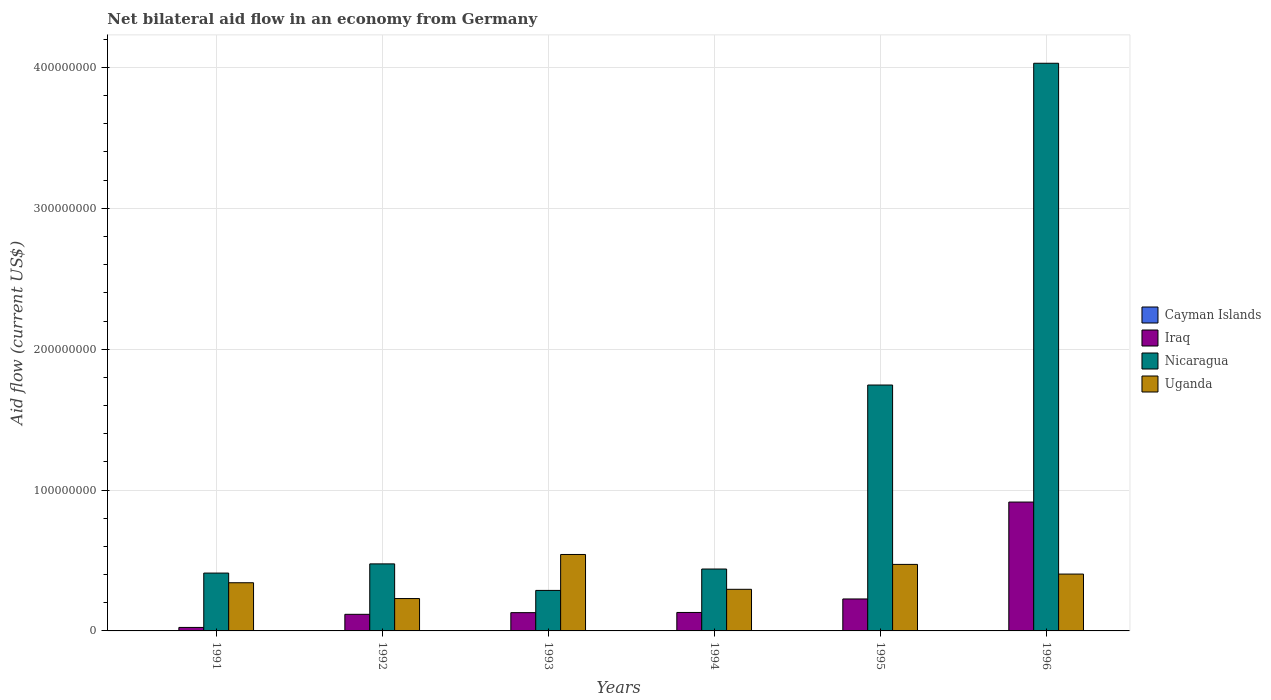Are the number of bars per tick equal to the number of legend labels?
Offer a very short reply. No. Are the number of bars on each tick of the X-axis equal?
Offer a very short reply. Yes. How many bars are there on the 1st tick from the right?
Your answer should be very brief. 3. What is the label of the 1st group of bars from the left?
Your answer should be compact. 1991. In how many cases, is the number of bars for a given year not equal to the number of legend labels?
Keep it short and to the point. 6. What is the net bilateral aid flow in Iraq in 1993?
Keep it short and to the point. 1.30e+07. Across all years, what is the maximum net bilateral aid flow in Uganda?
Your answer should be compact. 5.43e+07. Across all years, what is the minimum net bilateral aid flow in Nicaragua?
Your answer should be very brief. 2.88e+07. What is the total net bilateral aid flow in Iraq in the graph?
Keep it short and to the point. 1.55e+08. What is the difference between the net bilateral aid flow in Nicaragua in 1991 and that in 1995?
Ensure brevity in your answer.  -1.33e+08. What is the difference between the net bilateral aid flow in Iraq in 1993 and the net bilateral aid flow in Nicaragua in 1994?
Provide a succinct answer. -3.10e+07. What is the average net bilateral aid flow in Uganda per year?
Provide a short and direct response. 3.81e+07. In the year 1995, what is the difference between the net bilateral aid flow in Nicaragua and net bilateral aid flow in Uganda?
Keep it short and to the point. 1.27e+08. What is the ratio of the net bilateral aid flow in Uganda in 1994 to that in 1996?
Your response must be concise. 0.73. What is the difference between the highest and the second highest net bilateral aid flow in Uganda?
Ensure brevity in your answer.  7.05e+06. What is the difference between the highest and the lowest net bilateral aid flow in Iraq?
Make the answer very short. 8.90e+07. Is the sum of the net bilateral aid flow in Uganda in 1994 and 1996 greater than the maximum net bilateral aid flow in Nicaragua across all years?
Offer a very short reply. No. Is it the case that in every year, the sum of the net bilateral aid flow in Nicaragua and net bilateral aid flow in Uganda is greater than the net bilateral aid flow in Iraq?
Offer a terse response. Yes. How many bars are there?
Offer a very short reply. 18. How many years are there in the graph?
Your answer should be very brief. 6. Does the graph contain grids?
Give a very brief answer. Yes. What is the title of the graph?
Offer a very short reply. Net bilateral aid flow in an economy from Germany. What is the label or title of the X-axis?
Offer a terse response. Years. What is the label or title of the Y-axis?
Provide a short and direct response. Aid flow (current US$). What is the Aid flow (current US$) of Cayman Islands in 1991?
Ensure brevity in your answer.  0. What is the Aid flow (current US$) of Iraq in 1991?
Offer a terse response. 2.48e+06. What is the Aid flow (current US$) of Nicaragua in 1991?
Your answer should be very brief. 4.11e+07. What is the Aid flow (current US$) of Uganda in 1991?
Your answer should be very brief. 3.42e+07. What is the Aid flow (current US$) of Iraq in 1992?
Your response must be concise. 1.18e+07. What is the Aid flow (current US$) in Nicaragua in 1992?
Ensure brevity in your answer.  4.76e+07. What is the Aid flow (current US$) of Uganda in 1992?
Make the answer very short. 2.30e+07. What is the Aid flow (current US$) in Cayman Islands in 1993?
Make the answer very short. 0. What is the Aid flow (current US$) in Iraq in 1993?
Offer a terse response. 1.30e+07. What is the Aid flow (current US$) of Nicaragua in 1993?
Keep it short and to the point. 2.88e+07. What is the Aid flow (current US$) in Uganda in 1993?
Offer a terse response. 5.43e+07. What is the Aid flow (current US$) of Cayman Islands in 1994?
Keep it short and to the point. 0. What is the Aid flow (current US$) in Iraq in 1994?
Provide a succinct answer. 1.31e+07. What is the Aid flow (current US$) of Nicaragua in 1994?
Give a very brief answer. 4.39e+07. What is the Aid flow (current US$) in Uganda in 1994?
Provide a succinct answer. 2.95e+07. What is the Aid flow (current US$) in Iraq in 1995?
Provide a short and direct response. 2.27e+07. What is the Aid flow (current US$) in Nicaragua in 1995?
Keep it short and to the point. 1.75e+08. What is the Aid flow (current US$) in Uganda in 1995?
Your answer should be compact. 4.72e+07. What is the Aid flow (current US$) in Iraq in 1996?
Provide a short and direct response. 9.15e+07. What is the Aid flow (current US$) of Nicaragua in 1996?
Your answer should be compact. 4.03e+08. What is the Aid flow (current US$) in Uganda in 1996?
Keep it short and to the point. 4.04e+07. Across all years, what is the maximum Aid flow (current US$) in Iraq?
Ensure brevity in your answer.  9.15e+07. Across all years, what is the maximum Aid flow (current US$) in Nicaragua?
Provide a short and direct response. 4.03e+08. Across all years, what is the maximum Aid flow (current US$) of Uganda?
Your answer should be compact. 5.43e+07. Across all years, what is the minimum Aid flow (current US$) of Iraq?
Give a very brief answer. 2.48e+06. Across all years, what is the minimum Aid flow (current US$) of Nicaragua?
Give a very brief answer. 2.88e+07. Across all years, what is the minimum Aid flow (current US$) of Uganda?
Your answer should be compact. 2.30e+07. What is the total Aid flow (current US$) of Cayman Islands in the graph?
Your response must be concise. 0. What is the total Aid flow (current US$) in Iraq in the graph?
Provide a short and direct response. 1.55e+08. What is the total Aid flow (current US$) in Nicaragua in the graph?
Provide a short and direct response. 7.39e+08. What is the total Aid flow (current US$) in Uganda in the graph?
Your answer should be very brief. 2.29e+08. What is the difference between the Aid flow (current US$) of Iraq in 1991 and that in 1992?
Your answer should be compact. -9.31e+06. What is the difference between the Aid flow (current US$) in Nicaragua in 1991 and that in 1992?
Provide a succinct answer. -6.52e+06. What is the difference between the Aid flow (current US$) of Uganda in 1991 and that in 1992?
Offer a very short reply. 1.12e+07. What is the difference between the Aid flow (current US$) of Iraq in 1991 and that in 1993?
Make the answer very short. -1.05e+07. What is the difference between the Aid flow (current US$) of Nicaragua in 1991 and that in 1993?
Offer a very short reply. 1.23e+07. What is the difference between the Aid flow (current US$) of Uganda in 1991 and that in 1993?
Your answer should be compact. -2.01e+07. What is the difference between the Aid flow (current US$) of Iraq in 1991 and that in 1994?
Offer a terse response. -1.06e+07. What is the difference between the Aid flow (current US$) in Nicaragua in 1991 and that in 1994?
Keep it short and to the point. -2.87e+06. What is the difference between the Aid flow (current US$) of Uganda in 1991 and that in 1994?
Offer a terse response. 4.66e+06. What is the difference between the Aid flow (current US$) in Iraq in 1991 and that in 1995?
Ensure brevity in your answer.  -2.02e+07. What is the difference between the Aid flow (current US$) of Nicaragua in 1991 and that in 1995?
Give a very brief answer. -1.33e+08. What is the difference between the Aid flow (current US$) of Uganda in 1991 and that in 1995?
Make the answer very short. -1.30e+07. What is the difference between the Aid flow (current US$) of Iraq in 1991 and that in 1996?
Your response must be concise. -8.90e+07. What is the difference between the Aid flow (current US$) in Nicaragua in 1991 and that in 1996?
Your answer should be compact. -3.62e+08. What is the difference between the Aid flow (current US$) of Uganda in 1991 and that in 1996?
Your answer should be compact. -6.16e+06. What is the difference between the Aid flow (current US$) in Iraq in 1992 and that in 1993?
Your answer should be very brief. -1.18e+06. What is the difference between the Aid flow (current US$) in Nicaragua in 1992 and that in 1993?
Offer a terse response. 1.88e+07. What is the difference between the Aid flow (current US$) of Uganda in 1992 and that in 1993?
Provide a short and direct response. -3.13e+07. What is the difference between the Aid flow (current US$) of Iraq in 1992 and that in 1994?
Your response must be concise. -1.31e+06. What is the difference between the Aid flow (current US$) of Nicaragua in 1992 and that in 1994?
Your answer should be very brief. 3.65e+06. What is the difference between the Aid flow (current US$) in Uganda in 1992 and that in 1994?
Your response must be concise. -6.56e+06. What is the difference between the Aid flow (current US$) of Iraq in 1992 and that in 1995?
Provide a succinct answer. -1.09e+07. What is the difference between the Aid flow (current US$) of Nicaragua in 1992 and that in 1995?
Give a very brief answer. -1.27e+08. What is the difference between the Aid flow (current US$) in Uganda in 1992 and that in 1995?
Provide a succinct answer. -2.42e+07. What is the difference between the Aid flow (current US$) in Iraq in 1992 and that in 1996?
Keep it short and to the point. -7.97e+07. What is the difference between the Aid flow (current US$) in Nicaragua in 1992 and that in 1996?
Give a very brief answer. -3.55e+08. What is the difference between the Aid flow (current US$) of Uganda in 1992 and that in 1996?
Your answer should be compact. -1.74e+07. What is the difference between the Aid flow (current US$) in Iraq in 1993 and that in 1994?
Provide a short and direct response. -1.30e+05. What is the difference between the Aid flow (current US$) in Nicaragua in 1993 and that in 1994?
Your response must be concise. -1.52e+07. What is the difference between the Aid flow (current US$) of Uganda in 1993 and that in 1994?
Make the answer very short. 2.47e+07. What is the difference between the Aid flow (current US$) of Iraq in 1993 and that in 1995?
Ensure brevity in your answer.  -9.72e+06. What is the difference between the Aid flow (current US$) in Nicaragua in 1993 and that in 1995?
Your response must be concise. -1.46e+08. What is the difference between the Aid flow (current US$) in Uganda in 1993 and that in 1995?
Provide a short and direct response. 7.05e+06. What is the difference between the Aid flow (current US$) of Iraq in 1993 and that in 1996?
Provide a short and direct response. -7.85e+07. What is the difference between the Aid flow (current US$) of Nicaragua in 1993 and that in 1996?
Your answer should be compact. -3.74e+08. What is the difference between the Aid flow (current US$) in Uganda in 1993 and that in 1996?
Provide a short and direct response. 1.39e+07. What is the difference between the Aid flow (current US$) in Iraq in 1994 and that in 1995?
Provide a short and direct response. -9.59e+06. What is the difference between the Aid flow (current US$) in Nicaragua in 1994 and that in 1995?
Ensure brevity in your answer.  -1.31e+08. What is the difference between the Aid flow (current US$) of Uganda in 1994 and that in 1995?
Keep it short and to the point. -1.77e+07. What is the difference between the Aid flow (current US$) in Iraq in 1994 and that in 1996?
Your answer should be compact. -7.84e+07. What is the difference between the Aid flow (current US$) in Nicaragua in 1994 and that in 1996?
Make the answer very short. -3.59e+08. What is the difference between the Aid flow (current US$) in Uganda in 1994 and that in 1996?
Your answer should be very brief. -1.08e+07. What is the difference between the Aid flow (current US$) in Iraq in 1995 and that in 1996?
Provide a succinct answer. -6.88e+07. What is the difference between the Aid flow (current US$) in Nicaragua in 1995 and that in 1996?
Offer a terse response. -2.28e+08. What is the difference between the Aid flow (current US$) of Uganda in 1995 and that in 1996?
Ensure brevity in your answer.  6.86e+06. What is the difference between the Aid flow (current US$) of Iraq in 1991 and the Aid flow (current US$) of Nicaragua in 1992?
Your response must be concise. -4.51e+07. What is the difference between the Aid flow (current US$) in Iraq in 1991 and the Aid flow (current US$) in Uganda in 1992?
Provide a succinct answer. -2.05e+07. What is the difference between the Aid flow (current US$) in Nicaragua in 1991 and the Aid flow (current US$) in Uganda in 1992?
Ensure brevity in your answer.  1.81e+07. What is the difference between the Aid flow (current US$) in Iraq in 1991 and the Aid flow (current US$) in Nicaragua in 1993?
Ensure brevity in your answer.  -2.63e+07. What is the difference between the Aid flow (current US$) in Iraq in 1991 and the Aid flow (current US$) in Uganda in 1993?
Offer a terse response. -5.18e+07. What is the difference between the Aid flow (current US$) of Nicaragua in 1991 and the Aid flow (current US$) of Uganda in 1993?
Offer a very short reply. -1.32e+07. What is the difference between the Aid flow (current US$) in Iraq in 1991 and the Aid flow (current US$) in Nicaragua in 1994?
Provide a succinct answer. -4.15e+07. What is the difference between the Aid flow (current US$) of Iraq in 1991 and the Aid flow (current US$) of Uganda in 1994?
Make the answer very short. -2.71e+07. What is the difference between the Aid flow (current US$) of Nicaragua in 1991 and the Aid flow (current US$) of Uganda in 1994?
Your answer should be very brief. 1.15e+07. What is the difference between the Aid flow (current US$) in Iraq in 1991 and the Aid flow (current US$) in Nicaragua in 1995?
Your answer should be very brief. -1.72e+08. What is the difference between the Aid flow (current US$) in Iraq in 1991 and the Aid flow (current US$) in Uganda in 1995?
Keep it short and to the point. -4.47e+07. What is the difference between the Aid flow (current US$) in Nicaragua in 1991 and the Aid flow (current US$) in Uganda in 1995?
Your response must be concise. -6.15e+06. What is the difference between the Aid flow (current US$) in Iraq in 1991 and the Aid flow (current US$) in Nicaragua in 1996?
Your answer should be very brief. -4.00e+08. What is the difference between the Aid flow (current US$) in Iraq in 1991 and the Aid flow (current US$) in Uganda in 1996?
Provide a short and direct response. -3.79e+07. What is the difference between the Aid flow (current US$) in Nicaragua in 1991 and the Aid flow (current US$) in Uganda in 1996?
Ensure brevity in your answer.  7.10e+05. What is the difference between the Aid flow (current US$) of Iraq in 1992 and the Aid flow (current US$) of Nicaragua in 1993?
Keep it short and to the point. -1.70e+07. What is the difference between the Aid flow (current US$) in Iraq in 1992 and the Aid flow (current US$) in Uganda in 1993?
Your answer should be compact. -4.25e+07. What is the difference between the Aid flow (current US$) in Nicaragua in 1992 and the Aid flow (current US$) in Uganda in 1993?
Make the answer very short. -6.68e+06. What is the difference between the Aid flow (current US$) of Iraq in 1992 and the Aid flow (current US$) of Nicaragua in 1994?
Offer a very short reply. -3.22e+07. What is the difference between the Aid flow (current US$) of Iraq in 1992 and the Aid flow (current US$) of Uganda in 1994?
Provide a short and direct response. -1.78e+07. What is the difference between the Aid flow (current US$) of Nicaragua in 1992 and the Aid flow (current US$) of Uganda in 1994?
Your response must be concise. 1.80e+07. What is the difference between the Aid flow (current US$) of Iraq in 1992 and the Aid flow (current US$) of Nicaragua in 1995?
Offer a very short reply. -1.63e+08. What is the difference between the Aid flow (current US$) of Iraq in 1992 and the Aid flow (current US$) of Uganda in 1995?
Ensure brevity in your answer.  -3.54e+07. What is the difference between the Aid flow (current US$) of Iraq in 1992 and the Aid flow (current US$) of Nicaragua in 1996?
Provide a short and direct response. -3.91e+08. What is the difference between the Aid flow (current US$) in Iraq in 1992 and the Aid flow (current US$) in Uganda in 1996?
Give a very brief answer. -2.86e+07. What is the difference between the Aid flow (current US$) in Nicaragua in 1992 and the Aid flow (current US$) in Uganda in 1996?
Offer a very short reply. 7.23e+06. What is the difference between the Aid flow (current US$) in Iraq in 1993 and the Aid flow (current US$) in Nicaragua in 1994?
Make the answer very short. -3.10e+07. What is the difference between the Aid flow (current US$) in Iraq in 1993 and the Aid flow (current US$) in Uganda in 1994?
Provide a short and direct response. -1.66e+07. What is the difference between the Aid flow (current US$) in Nicaragua in 1993 and the Aid flow (current US$) in Uganda in 1994?
Make the answer very short. -7.80e+05. What is the difference between the Aid flow (current US$) of Iraq in 1993 and the Aid flow (current US$) of Nicaragua in 1995?
Provide a succinct answer. -1.62e+08. What is the difference between the Aid flow (current US$) of Iraq in 1993 and the Aid flow (current US$) of Uganda in 1995?
Offer a very short reply. -3.42e+07. What is the difference between the Aid flow (current US$) of Nicaragua in 1993 and the Aid flow (current US$) of Uganda in 1995?
Your answer should be compact. -1.85e+07. What is the difference between the Aid flow (current US$) in Iraq in 1993 and the Aid flow (current US$) in Nicaragua in 1996?
Your answer should be very brief. -3.90e+08. What is the difference between the Aid flow (current US$) in Iraq in 1993 and the Aid flow (current US$) in Uganda in 1996?
Offer a terse response. -2.74e+07. What is the difference between the Aid flow (current US$) of Nicaragua in 1993 and the Aid flow (current US$) of Uganda in 1996?
Make the answer very short. -1.16e+07. What is the difference between the Aid flow (current US$) of Iraq in 1994 and the Aid flow (current US$) of Nicaragua in 1995?
Your response must be concise. -1.61e+08. What is the difference between the Aid flow (current US$) of Iraq in 1994 and the Aid flow (current US$) of Uganda in 1995?
Give a very brief answer. -3.41e+07. What is the difference between the Aid flow (current US$) of Nicaragua in 1994 and the Aid flow (current US$) of Uganda in 1995?
Your answer should be very brief. -3.28e+06. What is the difference between the Aid flow (current US$) in Iraq in 1994 and the Aid flow (current US$) in Nicaragua in 1996?
Keep it short and to the point. -3.90e+08. What is the difference between the Aid flow (current US$) of Iraq in 1994 and the Aid flow (current US$) of Uganda in 1996?
Offer a very short reply. -2.73e+07. What is the difference between the Aid flow (current US$) in Nicaragua in 1994 and the Aid flow (current US$) in Uganda in 1996?
Your response must be concise. 3.58e+06. What is the difference between the Aid flow (current US$) in Iraq in 1995 and the Aid flow (current US$) in Nicaragua in 1996?
Offer a terse response. -3.80e+08. What is the difference between the Aid flow (current US$) in Iraq in 1995 and the Aid flow (current US$) in Uganda in 1996?
Ensure brevity in your answer.  -1.77e+07. What is the difference between the Aid flow (current US$) of Nicaragua in 1995 and the Aid flow (current US$) of Uganda in 1996?
Ensure brevity in your answer.  1.34e+08. What is the average Aid flow (current US$) of Iraq per year?
Your answer should be very brief. 2.58e+07. What is the average Aid flow (current US$) of Nicaragua per year?
Provide a succinct answer. 1.23e+08. What is the average Aid flow (current US$) of Uganda per year?
Keep it short and to the point. 3.81e+07. In the year 1991, what is the difference between the Aid flow (current US$) in Iraq and Aid flow (current US$) in Nicaragua?
Your response must be concise. -3.86e+07. In the year 1991, what is the difference between the Aid flow (current US$) of Iraq and Aid flow (current US$) of Uganda?
Provide a short and direct response. -3.17e+07. In the year 1991, what is the difference between the Aid flow (current US$) of Nicaragua and Aid flow (current US$) of Uganda?
Your response must be concise. 6.87e+06. In the year 1992, what is the difference between the Aid flow (current US$) of Iraq and Aid flow (current US$) of Nicaragua?
Offer a terse response. -3.58e+07. In the year 1992, what is the difference between the Aid flow (current US$) of Iraq and Aid flow (current US$) of Uganda?
Your answer should be very brief. -1.12e+07. In the year 1992, what is the difference between the Aid flow (current US$) of Nicaragua and Aid flow (current US$) of Uganda?
Your response must be concise. 2.46e+07. In the year 1993, what is the difference between the Aid flow (current US$) in Iraq and Aid flow (current US$) in Nicaragua?
Give a very brief answer. -1.58e+07. In the year 1993, what is the difference between the Aid flow (current US$) of Iraq and Aid flow (current US$) of Uganda?
Give a very brief answer. -4.13e+07. In the year 1993, what is the difference between the Aid flow (current US$) in Nicaragua and Aid flow (current US$) in Uganda?
Provide a short and direct response. -2.55e+07. In the year 1994, what is the difference between the Aid flow (current US$) of Iraq and Aid flow (current US$) of Nicaragua?
Provide a short and direct response. -3.08e+07. In the year 1994, what is the difference between the Aid flow (current US$) in Iraq and Aid flow (current US$) in Uganda?
Give a very brief answer. -1.64e+07. In the year 1994, what is the difference between the Aid flow (current US$) in Nicaragua and Aid flow (current US$) in Uganda?
Provide a short and direct response. 1.44e+07. In the year 1995, what is the difference between the Aid flow (current US$) in Iraq and Aid flow (current US$) in Nicaragua?
Give a very brief answer. -1.52e+08. In the year 1995, what is the difference between the Aid flow (current US$) of Iraq and Aid flow (current US$) of Uganda?
Offer a terse response. -2.45e+07. In the year 1995, what is the difference between the Aid flow (current US$) of Nicaragua and Aid flow (current US$) of Uganda?
Your answer should be compact. 1.27e+08. In the year 1996, what is the difference between the Aid flow (current US$) in Iraq and Aid flow (current US$) in Nicaragua?
Offer a very short reply. -3.12e+08. In the year 1996, what is the difference between the Aid flow (current US$) of Iraq and Aid flow (current US$) of Uganda?
Ensure brevity in your answer.  5.11e+07. In the year 1996, what is the difference between the Aid flow (current US$) of Nicaragua and Aid flow (current US$) of Uganda?
Keep it short and to the point. 3.63e+08. What is the ratio of the Aid flow (current US$) of Iraq in 1991 to that in 1992?
Make the answer very short. 0.21. What is the ratio of the Aid flow (current US$) of Nicaragua in 1991 to that in 1992?
Provide a succinct answer. 0.86. What is the ratio of the Aid flow (current US$) of Uganda in 1991 to that in 1992?
Offer a very short reply. 1.49. What is the ratio of the Aid flow (current US$) in Iraq in 1991 to that in 1993?
Your response must be concise. 0.19. What is the ratio of the Aid flow (current US$) of Nicaragua in 1991 to that in 1993?
Your response must be concise. 1.43. What is the ratio of the Aid flow (current US$) of Uganda in 1991 to that in 1993?
Your answer should be compact. 0.63. What is the ratio of the Aid flow (current US$) of Iraq in 1991 to that in 1994?
Provide a succinct answer. 0.19. What is the ratio of the Aid flow (current US$) in Nicaragua in 1991 to that in 1994?
Your response must be concise. 0.93. What is the ratio of the Aid flow (current US$) of Uganda in 1991 to that in 1994?
Your answer should be compact. 1.16. What is the ratio of the Aid flow (current US$) in Iraq in 1991 to that in 1995?
Make the answer very short. 0.11. What is the ratio of the Aid flow (current US$) in Nicaragua in 1991 to that in 1995?
Ensure brevity in your answer.  0.24. What is the ratio of the Aid flow (current US$) in Uganda in 1991 to that in 1995?
Your answer should be compact. 0.72. What is the ratio of the Aid flow (current US$) in Iraq in 1991 to that in 1996?
Keep it short and to the point. 0.03. What is the ratio of the Aid flow (current US$) of Nicaragua in 1991 to that in 1996?
Offer a very short reply. 0.1. What is the ratio of the Aid flow (current US$) in Uganda in 1991 to that in 1996?
Offer a terse response. 0.85. What is the ratio of the Aid flow (current US$) of Iraq in 1992 to that in 1993?
Make the answer very short. 0.91. What is the ratio of the Aid flow (current US$) in Nicaragua in 1992 to that in 1993?
Provide a succinct answer. 1.65. What is the ratio of the Aid flow (current US$) in Uganda in 1992 to that in 1993?
Offer a terse response. 0.42. What is the ratio of the Aid flow (current US$) in Iraq in 1992 to that in 1994?
Ensure brevity in your answer.  0.9. What is the ratio of the Aid flow (current US$) of Nicaragua in 1992 to that in 1994?
Give a very brief answer. 1.08. What is the ratio of the Aid flow (current US$) of Uganda in 1992 to that in 1994?
Provide a short and direct response. 0.78. What is the ratio of the Aid flow (current US$) of Iraq in 1992 to that in 1995?
Offer a very short reply. 0.52. What is the ratio of the Aid flow (current US$) of Nicaragua in 1992 to that in 1995?
Keep it short and to the point. 0.27. What is the ratio of the Aid flow (current US$) of Uganda in 1992 to that in 1995?
Offer a very short reply. 0.49. What is the ratio of the Aid flow (current US$) in Iraq in 1992 to that in 1996?
Give a very brief answer. 0.13. What is the ratio of the Aid flow (current US$) in Nicaragua in 1992 to that in 1996?
Give a very brief answer. 0.12. What is the ratio of the Aid flow (current US$) in Uganda in 1992 to that in 1996?
Provide a short and direct response. 0.57. What is the ratio of the Aid flow (current US$) of Nicaragua in 1993 to that in 1994?
Make the answer very short. 0.65. What is the ratio of the Aid flow (current US$) in Uganda in 1993 to that in 1994?
Keep it short and to the point. 1.84. What is the ratio of the Aid flow (current US$) of Iraq in 1993 to that in 1995?
Offer a terse response. 0.57. What is the ratio of the Aid flow (current US$) in Nicaragua in 1993 to that in 1995?
Offer a very short reply. 0.16. What is the ratio of the Aid flow (current US$) in Uganda in 1993 to that in 1995?
Your answer should be compact. 1.15. What is the ratio of the Aid flow (current US$) of Iraq in 1993 to that in 1996?
Make the answer very short. 0.14. What is the ratio of the Aid flow (current US$) of Nicaragua in 1993 to that in 1996?
Provide a short and direct response. 0.07. What is the ratio of the Aid flow (current US$) of Uganda in 1993 to that in 1996?
Your response must be concise. 1.34. What is the ratio of the Aid flow (current US$) in Iraq in 1994 to that in 1995?
Offer a very short reply. 0.58. What is the ratio of the Aid flow (current US$) in Nicaragua in 1994 to that in 1995?
Make the answer very short. 0.25. What is the ratio of the Aid flow (current US$) in Uganda in 1994 to that in 1995?
Provide a succinct answer. 0.63. What is the ratio of the Aid flow (current US$) of Iraq in 1994 to that in 1996?
Keep it short and to the point. 0.14. What is the ratio of the Aid flow (current US$) in Nicaragua in 1994 to that in 1996?
Provide a succinct answer. 0.11. What is the ratio of the Aid flow (current US$) in Uganda in 1994 to that in 1996?
Give a very brief answer. 0.73. What is the ratio of the Aid flow (current US$) of Iraq in 1995 to that in 1996?
Give a very brief answer. 0.25. What is the ratio of the Aid flow (current US$) of Nicaragua in 1995 to that in 1996?
Make the answer very short. 0.43. What is the ratio of the Aid flow (current US$) in Uganda in 1995 to that in 1996?
Your response must be concise. 1.17. What is the difference between the highest and the second highest Aid flow (current US$) of Iraq?
Your response must be concise. 6.88e+07. What is the difference between the highest and the second highest Aid flow (current US$) of Nicaragua?
Give a very brief answer. 2.28e+08. What is the difference between the highest and the second highest Aid flow (current US$) of Uganda?
Provide a succinct answer. 7.05e+06. What is the difference between the highest and the lowest Aid flow (current US$) of Iraq?
Your answer should be compact. 8.90e+07. What is the difference between the highest and the lowest Aid flow (current US$) of Nicaragua?
Offer a terse response. 3.74e+08. What is the difference between the highest and the lowest Aid flow (current US$) of Uganda?
Keep it short and to the point. 3.13e+07. 